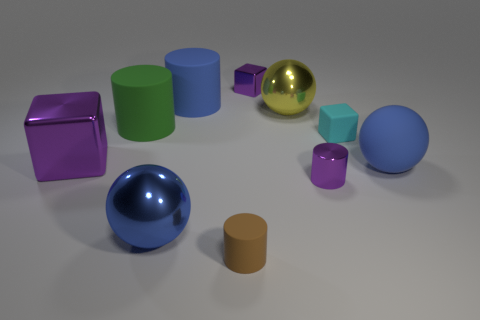Are there an equal number of large matte balls in front of the small brown thing and big green cylinders behind the large blue metallic sphere?
Your answer should be very brief. No. There is a big blue shiny thing; what number of tiny objects are behind it?
Your response must be concise. 3. How many objects are small objects or green rubber things?
Ensure brevity in your answer.  5. What number of yellow metal cylinders have the same size as the green rubber cylinder?
Your answer should be compact. 0. The large blue matte object behind the shiny ball behind the large green rubber object is what shape?
Provide a succinct answer. Cylinder. Is the number of shiny things less than the number of large blue objects?
Make the answer very short. No. What is the color of the big metal sphere that is on the left side of the small purple block?
Your answer should be compact. Blue. What is the purple object that is behind the large matte sphere and in front of the green cylinder made of?
Keep it short and to the point. Metal. There is a tiny cyan thing that is the same material as the big blue cylinder; what is its shape?
Your answer should be compact. Cube. How many big purple metallic objects are on the right side of the blue sphere to the right of the yellow shiny sphere?
Make the answer very short. 0. 